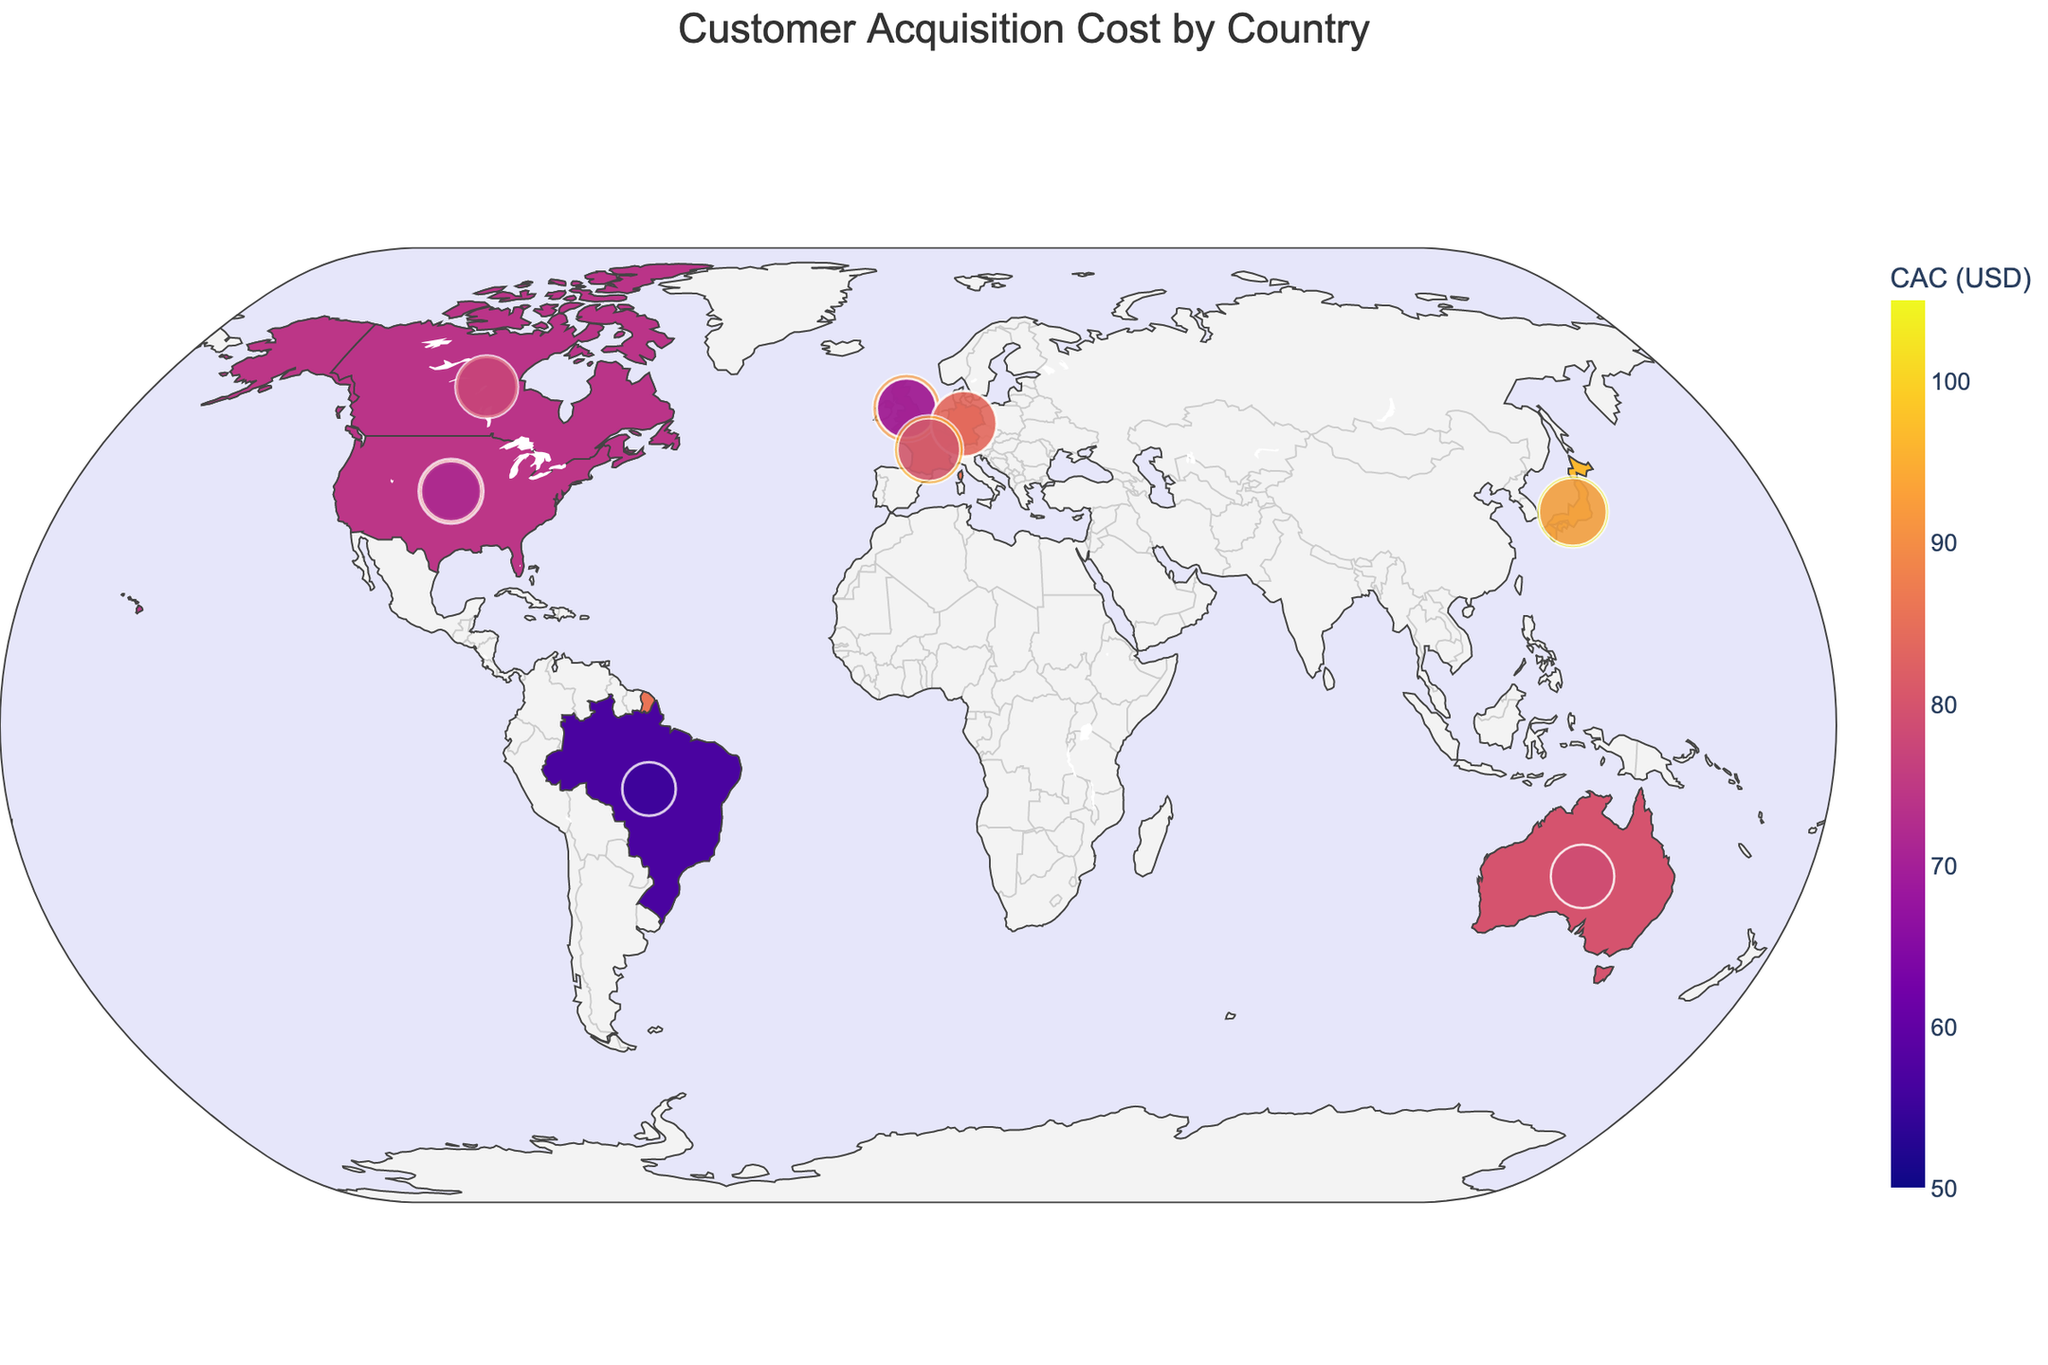What's the title of the plot? The title of the plot is displayed prominently at the top, indicating the main theme.
Answer: Customer Acquisition Cost by Country Which country has the highest customer acquisition cost? The country with the highest customer acquisition cost is typically highlighted in the darkest color on the choropleth map and by hovering over the countries to view details.
Answer: Japan What is the average customer acquisition cost for the United States? To find the average customer acquisition cost for the United States, check the hover details over the U.S. region. The average can be derived from the individual CAC values from different regions: (85.20 + 62.50 + 78.90 + 70.30) / 4 = 74.23
Answer: 74.23 How do the customer acquisition costs compare between Canada and the United Kingdom? By examining the choropleth map and the scatter overlays, compare the average CAC for both countries, which are shown by hovering over the countries. Canada shows moderate CAC, while the United Kingdom typically appears darker, indicating higher CACs.
Answer: The United Kingdom generally has higher CACs than Canada What is the range of the customer acquisition costs displayed in the plot? The color scale and legend provide the minimum and maximum values for customer acquisition costs, indicating the visible range.
Answer: 50 to 105 Which region in France has the lowest customer acquisition cost? By hovering over regions within France and examining scatter plot points, identify the region with the lowest CAC.
Answer: Provence-Alpes-Côte d'Azur Is there a region where the customer acquisition cost exceeds $100? By checking individual CAC values shown in the scatter plot and hovering over respective regions, look for any value above $100.
Answer: Yes, Tokyo, Japan exceeds $100 How does the customer acquisition cost in Southeast United States compare to Ontario, Canada? By checking the hover details of respective regions on the map, compare both values: Southeast United States at $70.30 and Ontario, Canada at $73.60.
Answer: Ontario has a slightly higher CAC What is the overall visual trend in customer acquisition costs across continents? By observing color gradients across different continents, the general trends such as higher costs in more developed regions and lower costs in developing regions become apparent.
Answer: Higher in developed countries, lower in developing countries Which country in South America is included in the plot, and what is its customer acquisition cost? By identifying South American countries on the map and checking hover details, spot Brazil and its respective CACs.
Answer: Brazil; $58.90 and $54.30 